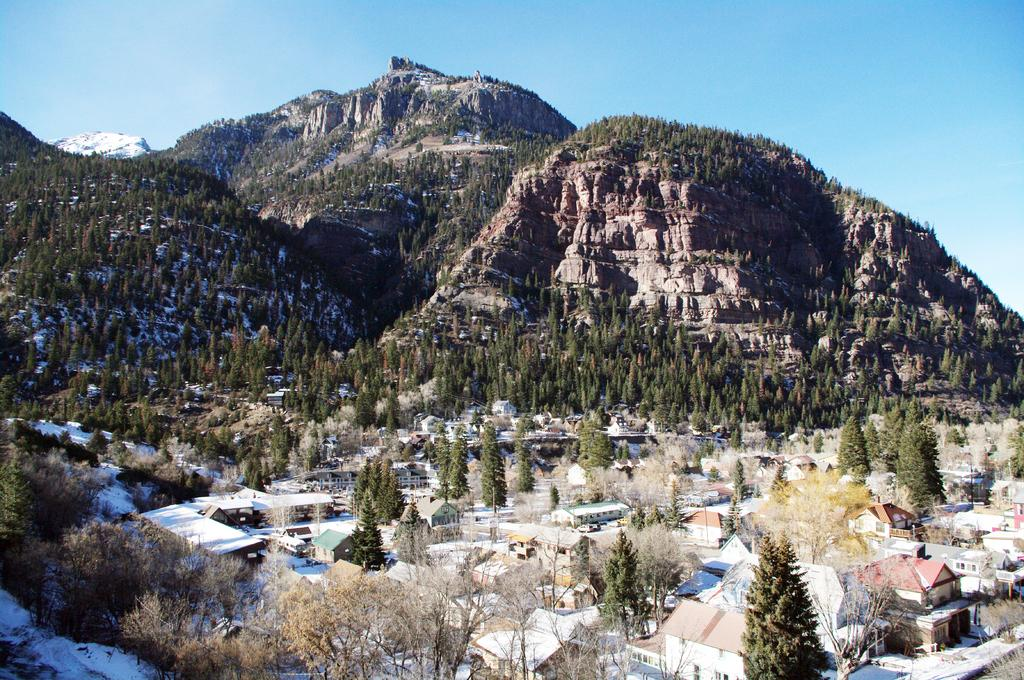What type of natural formation can be seen in the image? There are mountains in the image. What type of vegetation is present in the image? There are trees in the image. What type of human-made structures can be seen in the image? There are houses in the image. What type of man-made objects can be seen in the image? There are poles in the image. What type of weather condition is depicted in the image? There is snow on the left side bottom of the image, indicating a snowy condition. What is visible at the top of the image? The sky is clear and visible at the top of the image. What type of vegetable is being served for dinner in the image? There is no dinner or vegetable present in the image; it features mountains, trees, houses, poles, snow, and a clear sky. How many times does the person in the image bite the bit? There is no person or bit present in the image. 